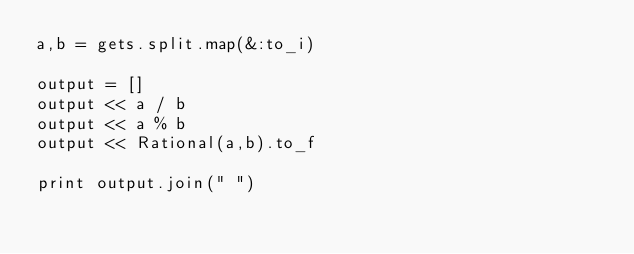Convert code to text. <code><loc_0><loc_0><loc_500><loc_500><_Ruby_>a,b = gets.split.map(&:to_i)

output = []
output << a / b
output << a % b
output << Rational(a,b).to_f

print output.join(" ")
</code> 